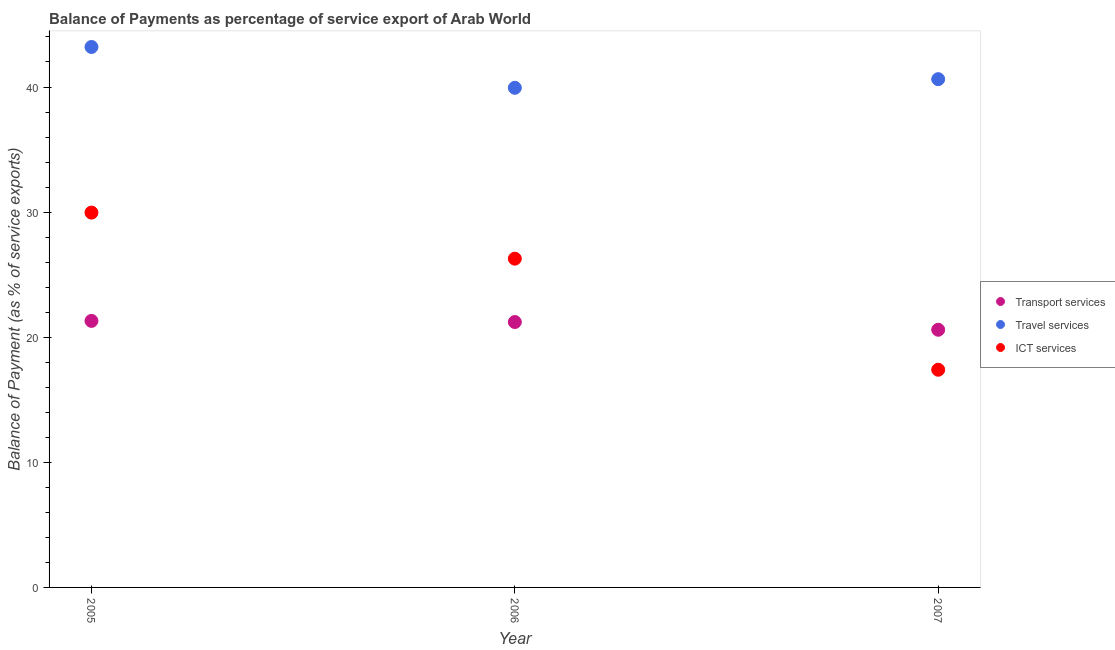What is the balance of payment of ict services in 2005?
Your answer should be very brief. 29.96. Across all years, what is the maximum balance of payment of transport services?
Give a very brief answer. 21.3. Across all years, what is the minimum balance of payment of travel services?
Offer a terse response. 39.94. In which year was the balance of payment of transport services minimum?
Keep it short and to the point. 2007. What is the total balance of payment of travel services in the graph?
Your response must be concise. 123.76. What is the difference between the balance of payment of transport services in 2006 and that in 2007?
Your response must be concise. 0.62. What is the difference between the balance of payment of travel services in 2007 and the balance of payment of transport services in 2006?
Make the answer very short. 19.41. What is the average balance of payment of travel services per year?
Your answer should be very brief. 41.25. In the year 2005, what is the difference between the balance of payment of ict services and balance of payment of travel services?
Offer a terse response. -13.24. What is the ratio of the balance of payment of ict services in 2006 to that in 2007?
Offer a terse response. 1.51. Is the balance of payment of transport services in 2005 less than that in 2006?
Ensure brevity in your answer.  No. What is the difference between the highest and the second highest balance of payment of ict services?
Your answer should be compact. 3.68. What is the difference between the highest and the lowest balance of payment of ict services?
Give a very brief answer. 12.56. In how many years, is the balance of payment of ict services greater than the average balance of payment of ict services taken over all years?
Ensure brevity in your answer.  2. Does the balance of payment of ict services monotonically increase over the years?
Make the answer very short. No. Is the balance of payment of transport services strictly greater than the balance of payment of ict services over the years?
Your answer should be compact. No. Is the balance of payment of transport services strictly less than the balance of payment of ict services over the years?
Your answer should be very brief. No. How many years are there in the graph?
Provide a short and direct response. 3. Are the values on the major ticks of Y-axis written in scientific E-notation?
Provide a succinct answer. No. Does the graph contain grids?
Offer a terse response. No. Where does the legend appear in the graph?
Provide a succinct answer. Center right. What is the title of the graph?
Offer a very short reply. Balance of Payments as percentage of service export of Arab World. Does "Central government" appear as one of the legend labels in the graph?
Make the answer very short. No. What is the label or title of the X-axis?
Keep it short and to the point. Year. What is the label or title of the Y-axis?
Your response must be concise. Balance of Payment (as % of service exports). What is the Balance of Payment (as % of service exports) of Transport services in 2005?
Your answer should be very brief. 21.3. What is the Balance of Payment (as % of service exports) of Travel services in 2005?
Your answer should be compact. 43.2. What is the Balance of Payment (as % of service exports) in ICT services in 2005?
Your answer should be very brief. 29.96. What is the Balance of Payment (as % of service exports) of Transport services in 2006?
Provide a short and direct response. 21.21. What is the Balance of Payment (as % of service exports) in Travel services in 2006?
Offer a terse response. 39.94. What is the Balance of Payment (as % of service exports) in ICT services in 2006?
Ensure brevity in your answer.  26.28. What is the Balance of Payment (as % of service exports) of Transport services in 2007?
Ensure brevity in your answer.  20.6. What is the Balance of Payment (as % of service exports) of Travel services in 2007?
Offer a very short reply. 40.63. What is the Balance of Payment (as % of service exports) of ICT services in 2007?
Provide a succinct answer. 17.4. Across all years, what is the maximum Balance of Payment (as % of service exports) of Transport services?
Keep it short and to the point. 21.3. Across all years, what is the maximum Balance of Payment (as % of service exports) of Travel services?
Ensure brevity in your answer.  43.2. Across all years, what is the maximum Balance of Payment (as % of service exports) of ICT services?
Your response must be concise. 29.96. Across all years, what is the minimum Balance of Payment (as % of service exports) in Transport services?
Offer a terse response. 20.6. Across all years, what is the minimum Balance of Payment (as % of service exports) of Travel services?
Make the answer very short. 39.94. Across all years, what is the minimum Balance of Payment (as % of service exports) of ICT services?
Your answer should be compact. 17.4. What is the total Balance of Payment (as % of service exports) of Transport services in the graph?
Give a very brief answer. 63.11. What is the total Balance of Payment (as % of service exports) in Travel services in the graph?
Your answer should be very brief. 123.76. What is the total Balance of Payment (as % of service exports) in ICT services in the graph?
Offer a terse response. 73.64. What is the difference between the Balance of Payment (as % of service exports) in Transport services in 2005 and that in 2006?
Provide a succinct answer. 0.09. What is the difference between the Balance of Payment (as % of service exports) in Travel services in 2005 and that in 2006?
Ensure brevity in your answer.  3.26. What is the difference between the Balance of Payment (as % of service exports) of ICT services in 2005 and that in 2006?
Make the answer very short. 3.68. What is the difference between the Balance of Payment (as % of service exports) of Transport services in 2005 and that in 2007?
Your response must be concise. 0.71. What is the difference between the Balance of Payment (as % of service exports) of Travel services in 2005 and that in 2007?
Your response must be concise. 2.57. What is the difference between the Balance of Payment (as % of service exports) of ICT services in 2005 and that in 2007?
Your answer should be very brief. 12.56. What is the difference between the Balance of Payment (as % of service exports) of Transport services in 2006 and that in 2007?
Offer a terse response. 0.62. What is the difference between the Balance of Payment (as % of service exports) in Travel services in 2006 and that in 2007?
Provide a succinct answer. -0.69. What is the difference between the Balance of Payment (as % of service exports) in ICT services in 2006 and that in 2007?
Offer a very short reply. 8.88. What is the difference between the Balance of Payment (as % of service exports) in Transport services in 2005 and the Balance of Payment (as % of service exports) in Travel services in 2006?
Give a very brief answer. -18.63. What is the difference between the Balance of Payment (as % of service exports) in Transport services in 2005 and the Balance of Payment (as % of service exports) in ICT services in 2006?
Make the answer very short. -4.97. What is the difference between the Balance of Payment (as % of service exports) in Travel services in 2005 and the Balance of Payment (as % of service exports) in ICT services in 2006?
Give a very brief answer. 16.92. What is the difference between the Balance of Payment (as % of service exports) of Transport services in 2005 and the Balance of Payment (as % of service exports) of Travel services in 2007?
Provide a short and direct response. -19.32. What is the difference between the Balance of Payment (as % of service exports) of Transport services in 2005 and the Balance of Payment (as % of service exports) of ICT services in 2007?
Provide a succinct answer. 3.9. What is the difference between the Balance of Payment (as % of service exports) in Travel services in 2005 and the Balance of Payment (as % of service exports) in ICT services in 2007?
Your answer should be very brief. 25.8. What is the difference between the Balance of Payment (as % of service exports) of Transport services in 2006 and the Balance of Payment (as % of service exports) of Travel services in 2007?
Offer a terse response. -19.41. What is the difference between the Balance of Payment (as % of service exports) in Transport services in 2006 and the Balance of Payment (as % of service exports) in ICT services in 2007?
Make the answer very short. 3.81. What is the difference between the Balance of Payment (as % of service exports) in Travel services in 2006 and the Balance of Payment (as % of service exports) in ICT services in 2007?
Provide a succinct answer. 22.54. What is the average Balance of Payment (as % of service exports) in Transport services per year?
Provide a succinct answer. 21.04. What is the average Balance of Payment (as % of service exports) of Travel services per year?
Ensure brevity in your answer.  41.25. What is the average Balance of Payment (as % of service exports) of ICT services per year?
Ensure brevity in your answer.  24.55. In the year 2005, what is the difference between the Balance of Payment (as % of service exports) in Transport services and Balance of Payment (as % of service exports) in Travel services?
Ensure brevity in your answer.  -21.9. In the year 2005, what is the difference between the Balance of Payment (as % of service exports) in Transport services and Balance of Payment (as % of service exports) in ICT services?
Offer a very short reply. -8.66. In the year 2005, what is the difference between the Balance of Payment (as % of service exports) in Travel services and Balance of Payment (as % of service exports) in ICT services?
Your answer should be very brief. 13.24. In the year 2006, what is the difference between the Balance of Payment (as % of service exports) in Transport services and Balance of Payment (as % of service exports) in Travel services?
Give a very brief answer. -18.72. In the year 2006, what is the difference between the Balance of Payment (as % of service exports) in Transport services and Balance of Payment (as % of service exports) in ICT services?
Make the answer very short. -5.06. In the year 2006, what is the difference between the Balance of Payment (as % of service exports) of Travel services and Balance of Payment (as % of service exports) of ICT services?
Your answer should be very brief. 13.66. In the year 2007, what is the difference between the Balance of Payment (as % of service exports) in Transport services and Balance of Payment (as % of service exports) in Travel services?
Your answer should be very brief. -20.03. In the year 2007, what is the difference between the Balance of Payment (as % of service exports) of Transport services and Balance of Payment (as % of service exports) of ICT services?
Your answer should be compact. 3.2. In the year 2007, what is the difference between the Balance of Payment (as % of service exports) in Travel services and Balance of Payment (as % of service exports) in ICT services?
Ensure brevity in your answer.  23.23. What is the ratio of the Balance of Payment (as % of service exports) of Travel services in 2005 to that in 2006?
Offer a terse response. 1.08. What is the ratio of the Balance of Payment (as % of service exports) of ICT services in 2005 to that in 2006?
Your answer should be very brief. 1.14. What is the ratio of the Balance of Payment (as % of service exports) of Transport services in 2005 to that in 2007?
Offer a terse response. 1.03. What is the ratio of the Balance of Payment (as % of service exports) of Travel services in 2005 to that in 2007?
Make the answer very short. 1.06. What is the ratio of the Balance of Payment (as % of service exports) in ICT services in 2005 to that in 2007?
Your response must be concise. 1.72. What is the ratio of the Balance of Payment (as % of service exports) in ICT services in 2006 to that in 2007?
Your answer should be compact. 1.51. What is the difference between the highest and the second highest Balance of Payment (as % of service exports) of Transport services?
Offer a very short reply. 0.09. What is the difference between the highest and the second highest Balance of Payment (as % of service exports) in Travel services?
Offer a very short reply. 2.57. What is the difference between the highest and the second highest Balance of Payment (as % of service exports) of ICT services?
Offer a very short reply. 3.68. What is the difference between the highest and the lowest Balance of Payment (as % of service exports) in Transport services?
Keep it short and to the point. 0.71. What is the difference between the highest and the lowest Balance of Payment (as % of service exports) in Travel services?
Give a very brief answer. 3.26. What is the difference between the highest and the lowest Balance of Payment (as % of service exports) of ICT services?
Keep it short and to the point. 12.56. 